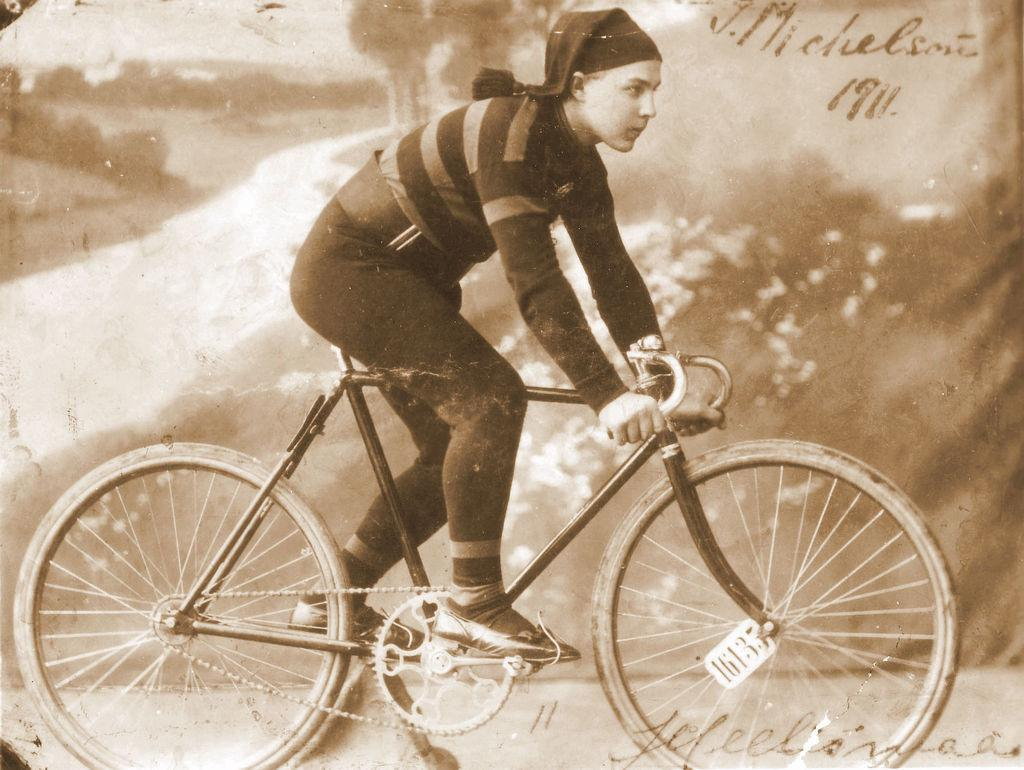What is the main subject of the image? There is a person in the image. What is the person doing in the image? The person is sitting on a bicycle. What is the color scheme of the image? The image is in black and white color. Can you see any cobwebs in the image? There are no cobwebs present in the image. Is the person in the image sinking into quicksand? There is no quicksand present in the image, and the person is sitting on a bicycle. 